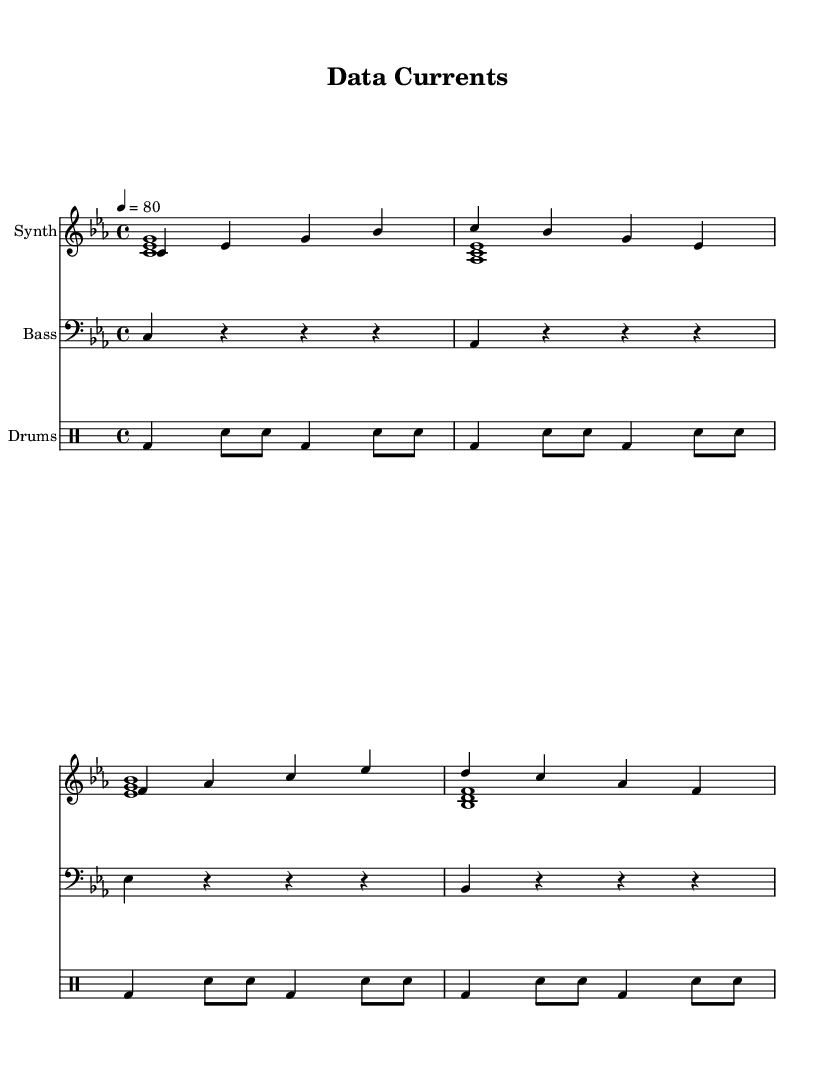What is the key signature of this music? The key signature is indicated at the beginning of the staff and shows three flats, which corresponds to C minor.
Answer: C minor What is the time signature of this piece? The time signature is shown at the beginning of the staff and is written as "4/4," which indicates four beats per measure.
Answer: 4/4 What is the tempo marking for this piece? The tempo marking is located near the top and is written as "4 = 80," indicating the speed of the piece, with "4" representing quarter note beats per minute.
Answer: 80 How many measures are there in the melody section? The melody section consists of four measures, as seen by counting the bar lines in the synthMelody staff.
Answer: 4 What type of drums are used in the drum pattern? The drum pattern uses a bass drum (bd) and snare (sn), indicated in the drum machine notation.
Answer: Bass drum and snare What type of harmony is utilized in the piece? The harmony is built with stacked notes in three-note chords, indicating a rich, layered sound that is typical in ambient-industrial music.
Answer: Three-note chords Is there any silence in the electric bass part? Yes, the electric bass part includes rests, as represented by the "r" symbols in the notation, indicating pauses.
Answer: Yes 